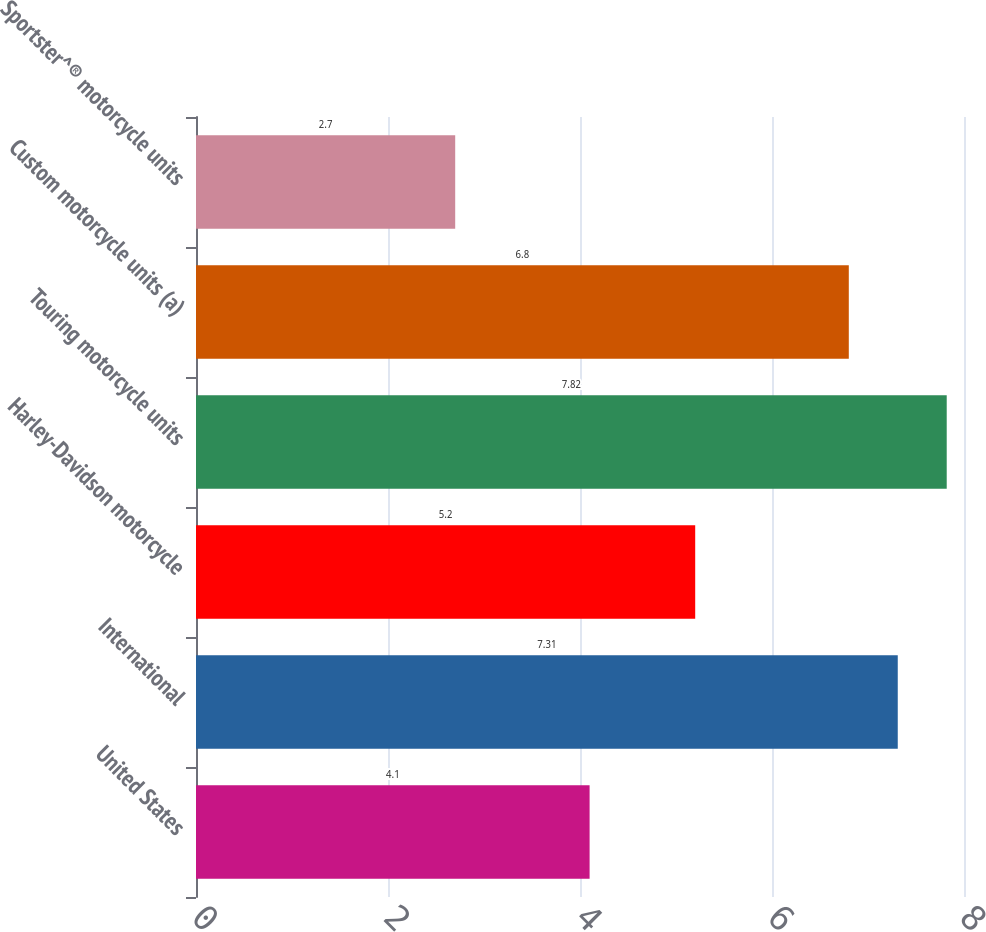Convert chart to OTSL. <chart><loc_0><loc_0><loc_500><loc_500><bar_chart><fcel>United States<fcel>International<fcel>Harley-Davidson motorcycle<fcel>Touring motorcycle units<fcel>Custom motorcycle units (a)<fcel>Sportster^® motorcycle units<nl><fcel>4.1<fcel>7.31<fcel>5.2<fcel>7.82<fcel>6.8<fcel>2.7<nl></chart> 